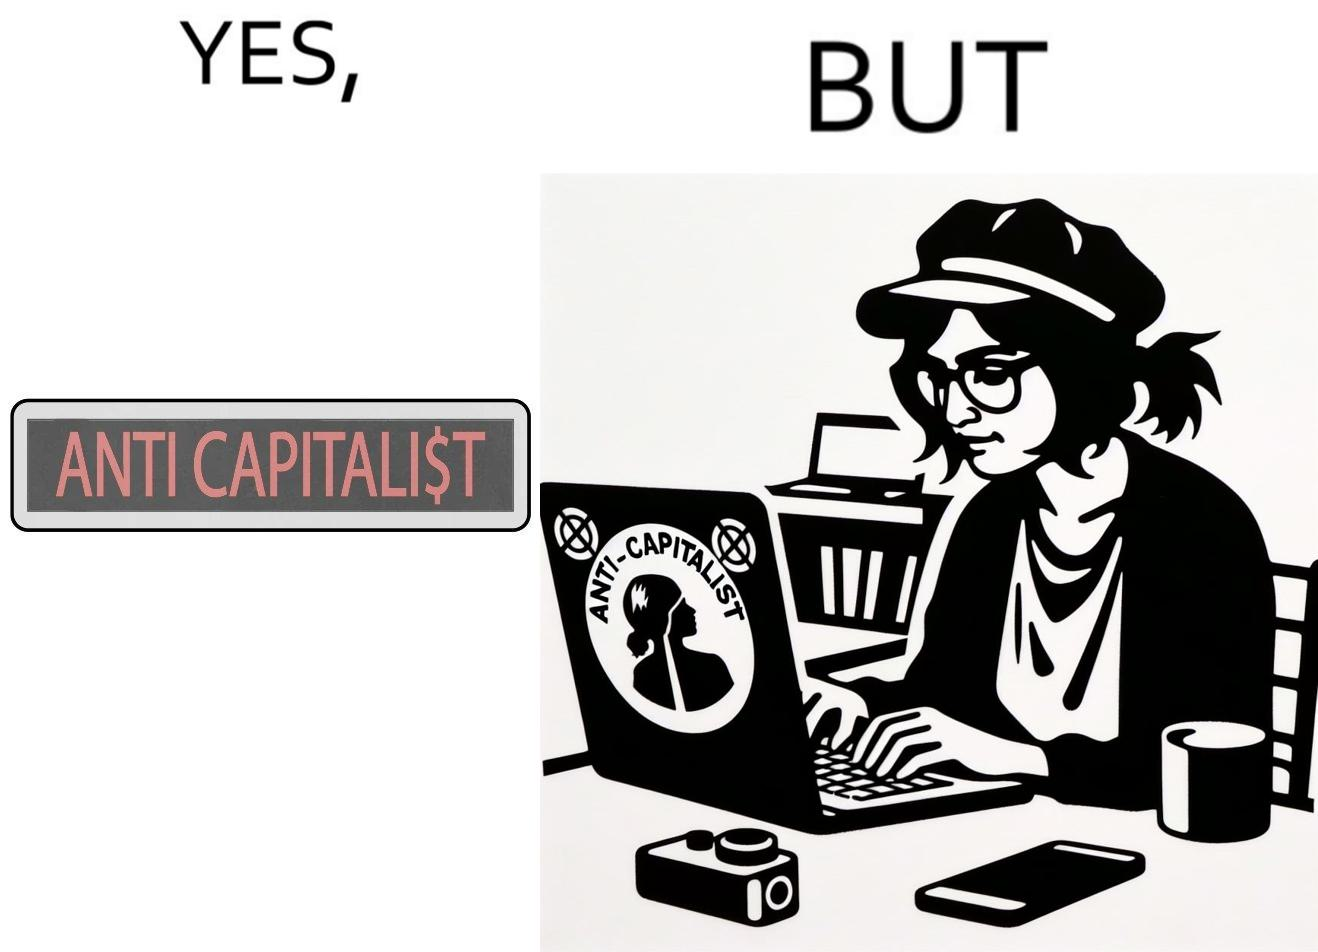Describe the content of this image. The overall image is ironical because the people who claim to be anticapitalist are the ones with a lot of capital as shown here. While the woman supports anticapitalism as shown by the sticker on the back of her laptop, she has a phone, a camera and a laptop all of which require money. 